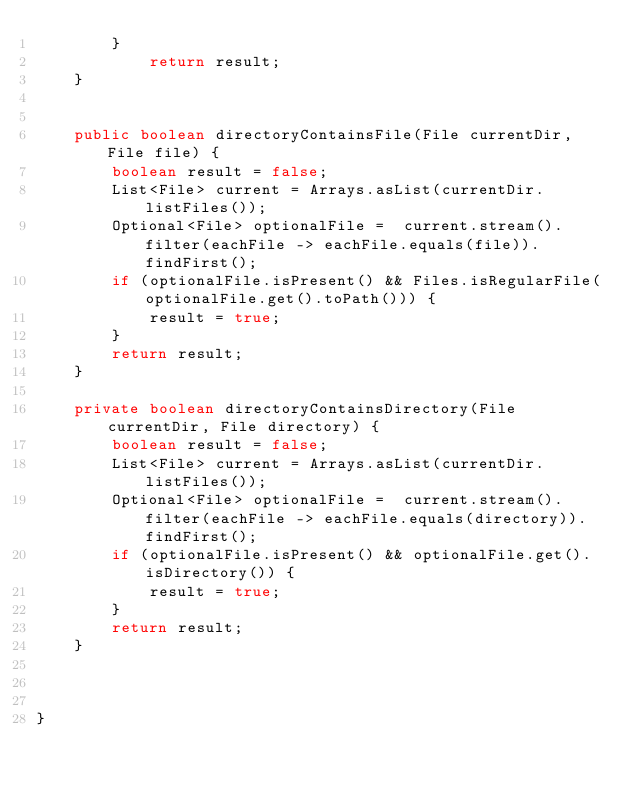Convert code to text. <code><loc_0><loc_0><loc_500><loc_500><_Java_>        }
            return result;
    }


    public boolean directoryContainsFile(File currentDir, File file) {
        boolean result = false;
        List<File> current = Arrays.asList(currentDir.listFiles());
        Optional<File> optionalFile =  current.stream().filter(eachFile -> eachFile.equals(file)).findFirst();
        if (optionalFile.isPresent() && Files.isRegularFile(optionalFile.get().toPath())) {
            result = true;
        }
        return result;
    }

    private boolean directoryContainsDirectory(File currentDir, File directory) {
        boolean result = false;
        List<File> current = Arrays.asList(currentDir.listFiles());
        Optional<File> optionalFile =  current.stream().filter(eachFile -> eachFile.equals(directory)).findFirst();
        if (optionalFile.isPresent() && optionalFile.get().isDirectory()) {
            result = true;
        }
        return result;
    }



}
</code> 